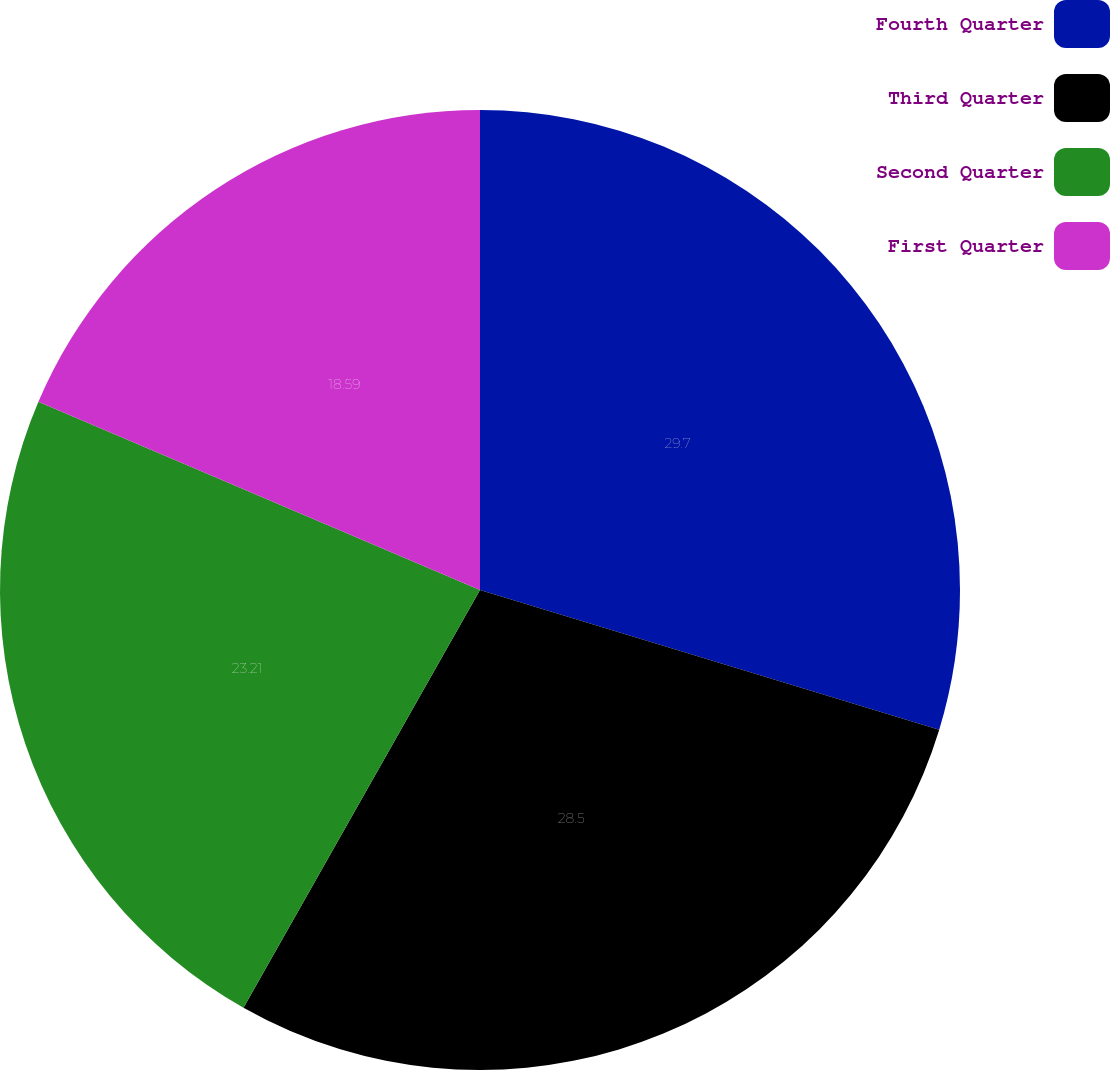<chart> <loc_0><loc_0><loc_500><loc_500><pie_chart><fcel>Fourth Quarter<fcel>Third Quarter<fcel>Second Quarter<fcel>First Quarter<nl><fcel>29.7%<fcel>28.5%<fcel>23.21%<fcel>18.59%<nl></chart> 